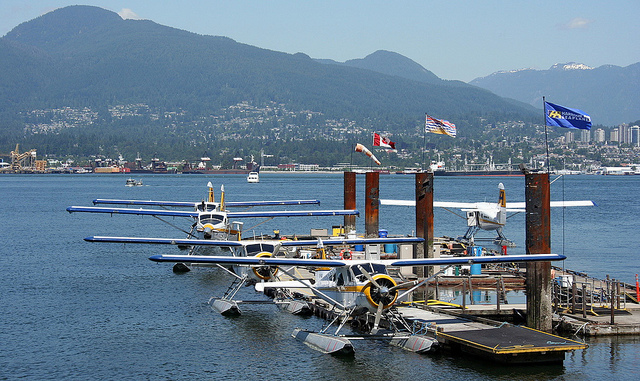Please extract the text content from this image. A 